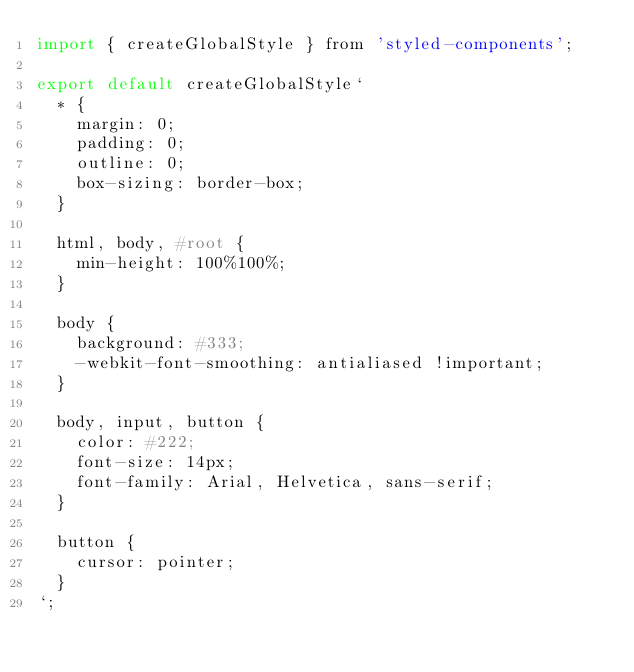<code> <loc_0><loc_0><loc_500><loc_500><_JavaScript_>import { createGlobalStyle } from 'styled-components';

export default createGlobalStyle`
  * {
    margin: 0;
    padding: 0;
    outline: 0;
    box-sizing: border-box;
  }

  html, body, #root {
    min-height: 100%100%;
  }

  body {
    background: #333;
    -webkit-font-smoothing: antialiased !important;
  }

  body, input, button {
    color: #222;
    font-size: 14px;
    font-family: Arial, Helvetica, sans-serif;
  }

  button {
    cursor: pointer;
  }
`;
</code> 